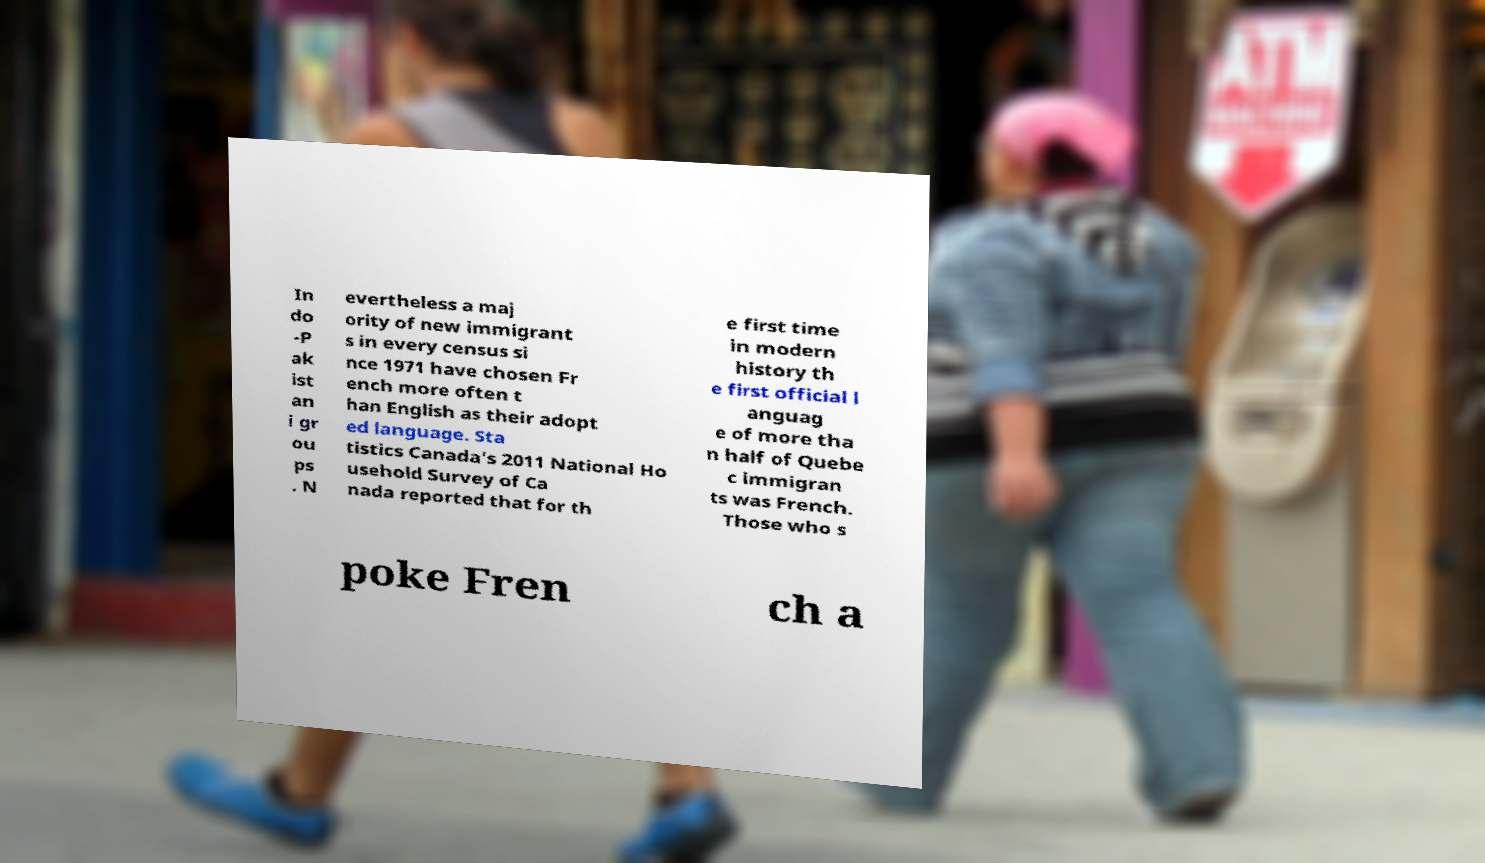Could you extract and type out the text from this image? In do -P ak ist an i gr ou ps . N evertheless a maj ority of new immigrant s in every census si nce 1971 have chosen Fr ench more often t han English as their adopt ed language. Sta tistics Canada's 2011 National Ho usehold Survey of Ca nada reported that for th e first time in modern history th e first official l anguag e of more tha n half of Quebe c immigran ts was French. Those who s poke Fren ch a 